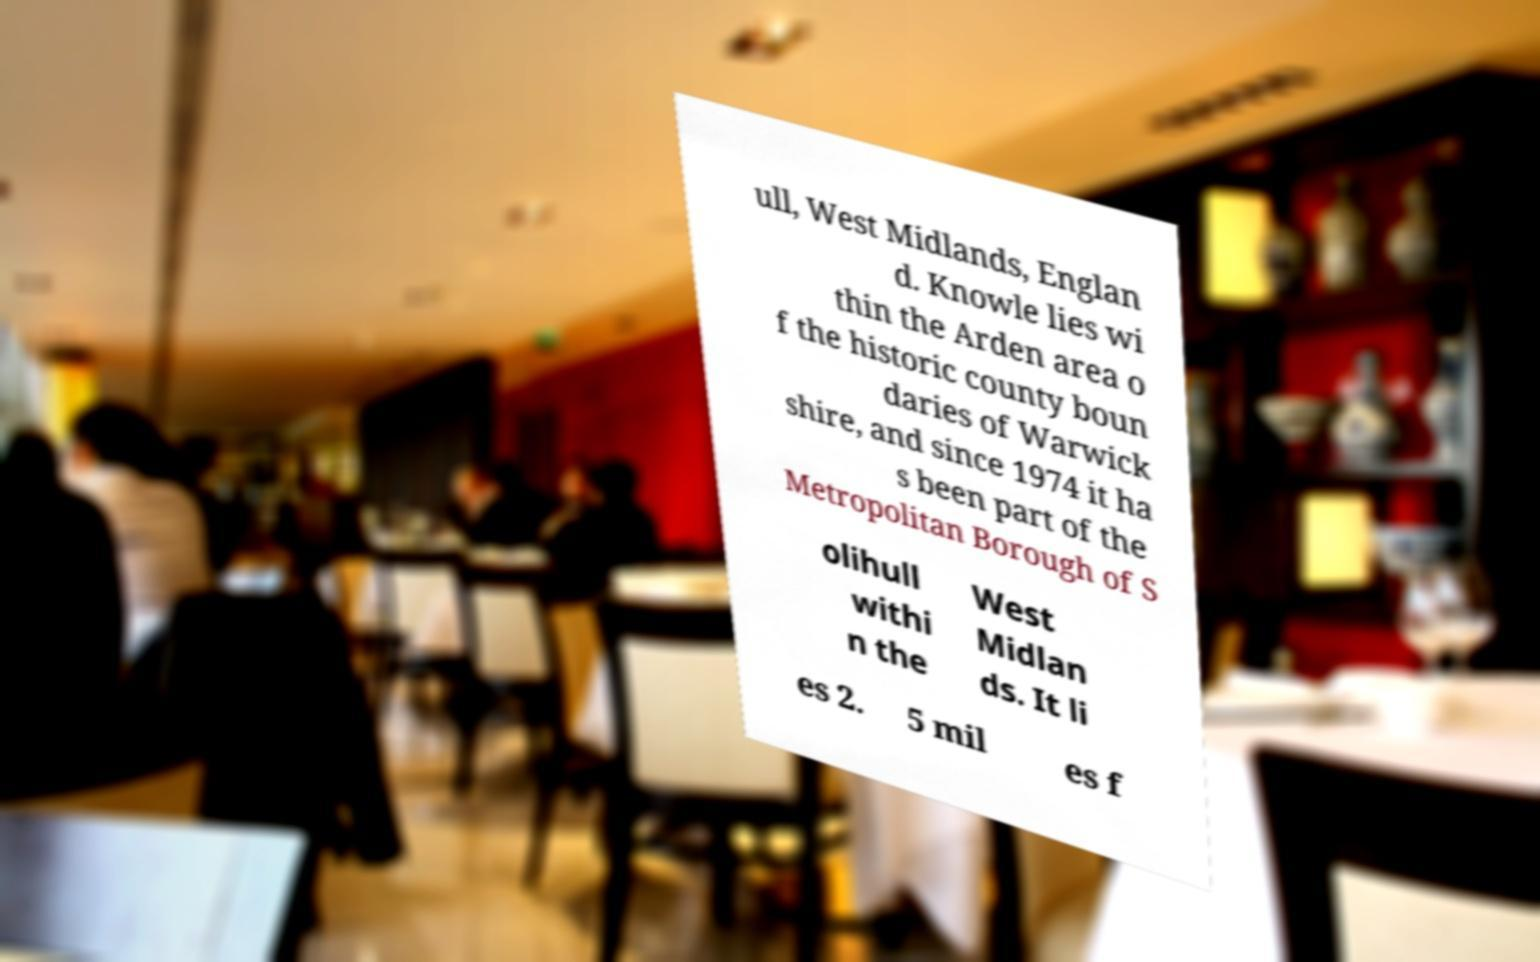Can you accurately transcribe the text from the provided image for me? ull, West Midlands, Englan d. Knowle lies wi thin the Arden area o f the historic county boun daries of Warwick shire, and since 1974 it ha s been part of the Metropolitan Borough of S olihull withi n the West Midlan ds. It li es 2. 5 mil es f 